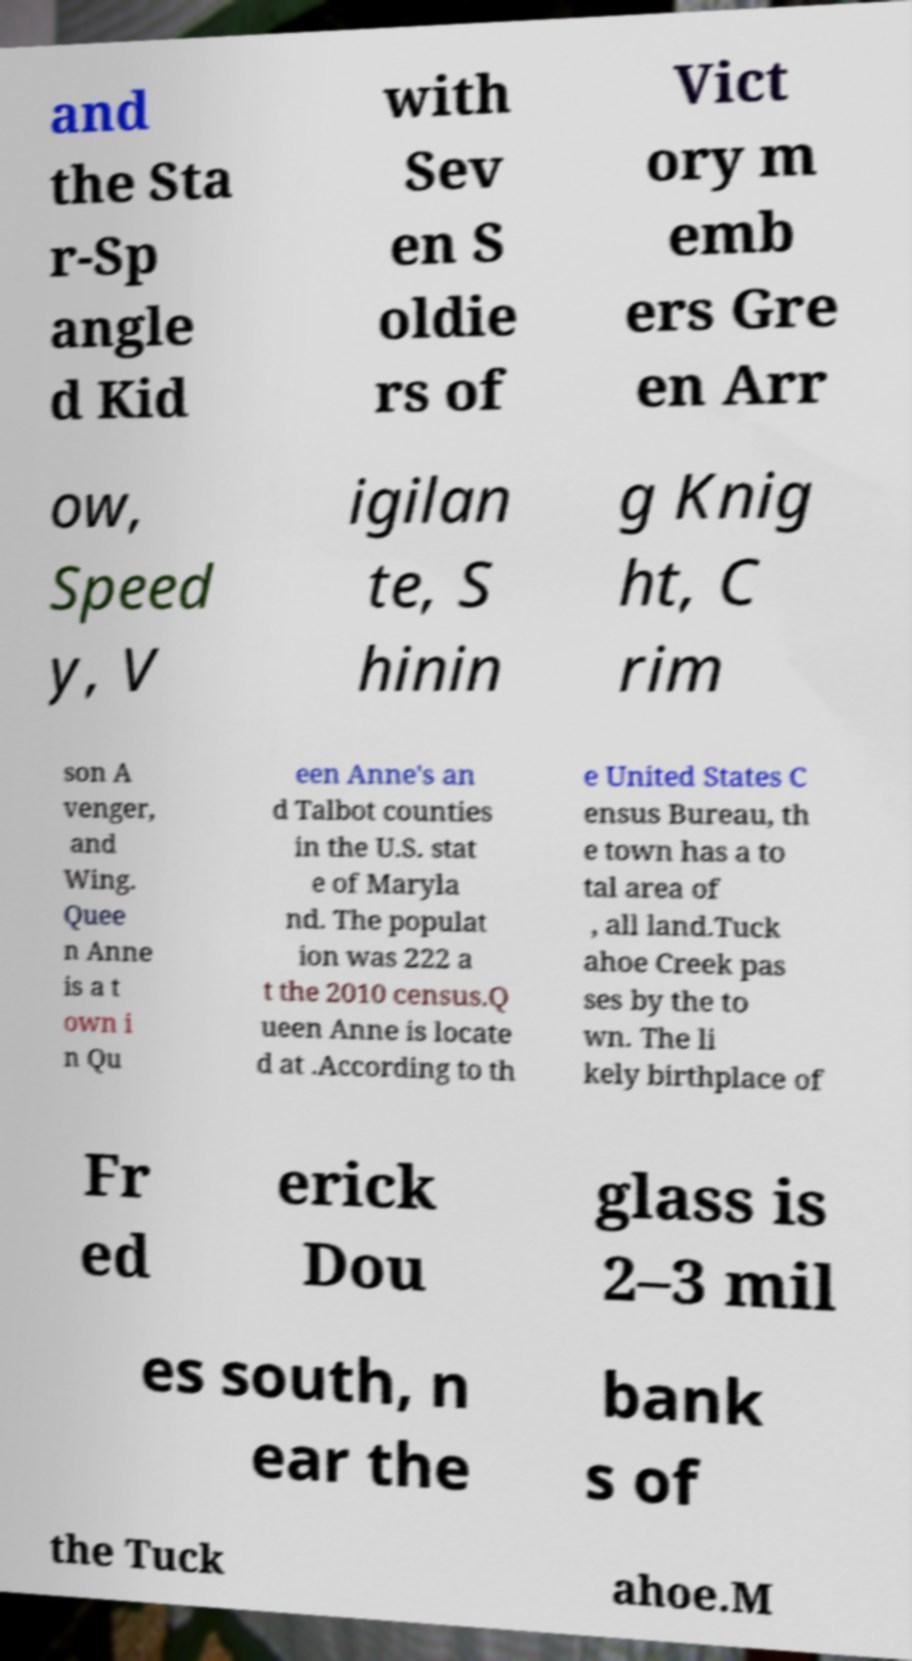Can you accurately transcribe the text from the provided image for me? and the Sta r-Sp angle d Kid with Sev en S oldie rs of Vict ory m emb ers Gre en Arr ow, Speed y, V igilan te, S hinin g Knig ht, C rim son A venger, and Wing. Quee n Anne is a t own i n Qu een Anne's an d Talbot counties in the U.S. stat e of Maryla nd. The populat ion was 222 a t the 2010 census.Q ueen Anne is locate d at .According to th e United States C ensus Bureau, th e town has a to tal area of , all land.Tuck ahoe Creek pas ses by the to wn. The li kely birthplace of Fr ed erick Dou glass is 2–3 mil es south, n ear the bank s of the Tuck ahoe.M 